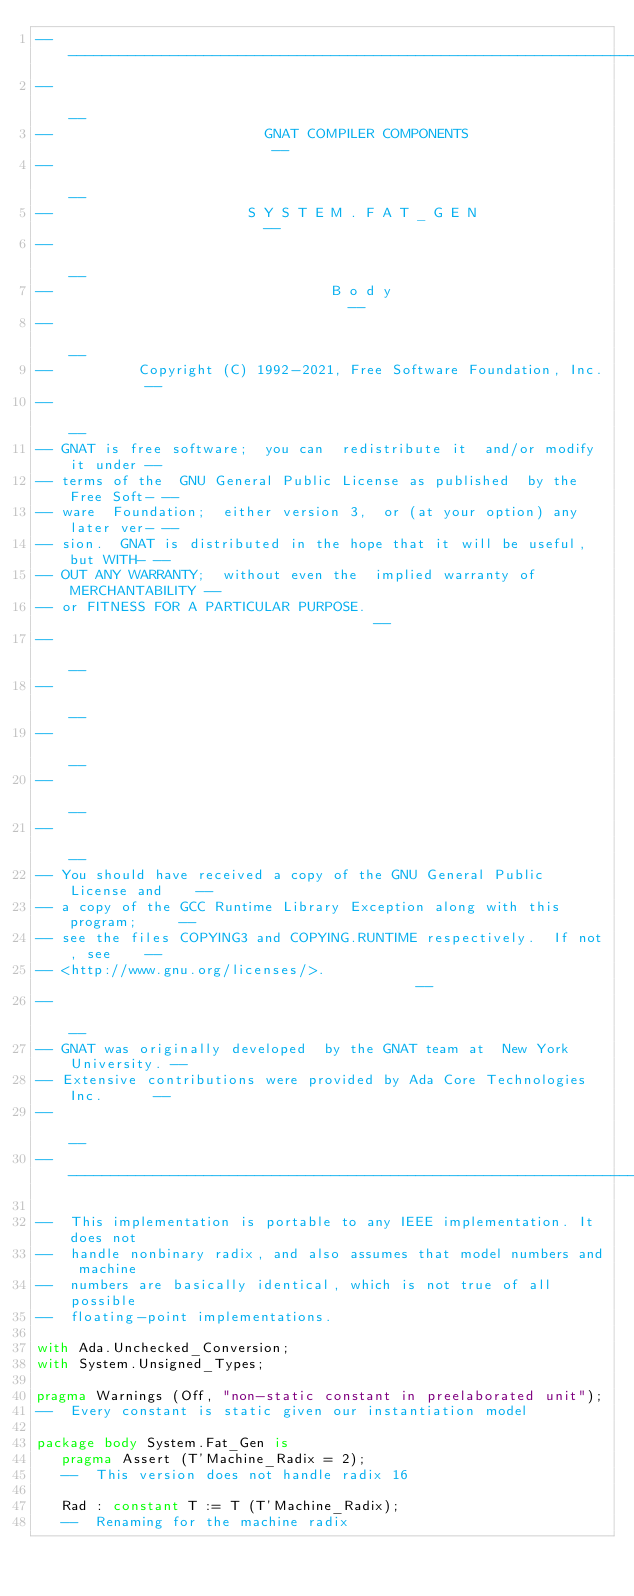Convert code to text. <code><loc_0><loc_0><loc_500><loc_500><_Ada_>------------------------------------------------------------------------------
--                                                                          --
--                         GNAT COMPILER COMPONENTS                         --
--                                                                          --
--                       S Y S T E M . F A T _ G E N                        --
--                                                                          --
--                                 B o d y                                  --
--                                                                          --
--          Copyright (C) 1992-2021, Free Software Foundation, Inc.         --
--                                                                          --
-- GNAT is free software;  you can  redistribute it  and/or modify it under --
-- terms of the  GNU General Public License as published  by the Free Soft- --
-- ware  Foundation;  either version 3,  or (at your option) any later ver- --
-- sion.  GNAT is distributed in the hope that it will be useful, but WITH- --
-- OUT ANY WARRANTY;  without even the  implied warranty of MERCHANTABILITY --
-- or FITNESS FOR A PARTICULAR PURPOSE.                                     --
--                                                                          --
--                                                                          --
--                                                                          --
--                                                                          --
--                                                                          --
-- You should have received a copy of the GNU General Public License and    --
-- a copy of the GCC Runtime Library Exception along with this program;     --
-- see the files COPYING3 and COPYING.RUNTIME respectively.  If not, see    --
-- <http://www.gnu.org/licenses/>.                                          --
--                                                                          --
-- GNAT was originally developed  by the GNAT team at  New York University. --
-- Extensive contributions were provided by Ada Core Technologies Inc.      --
--                                                                          --
------------------------------------------------------------------------------

--  This implementation is portable to any IEEE implementation. It does not
--  handle nonbinary radix, and also assumes that model numbers and machine
--  numbers are basically identical, which is not true of all possible
--  floating-point implementations.

with Ada.Unchecked_Conversion;
with System.Unsigned_Types;

pragma Warnings (Off, "non-static constant in preelaborated unit");
--  Every constant is static given our instantiation model

package body System.Fat_Gen is
   pragma Assert (T'Machine_Radix = 2);
   --  This version does not handle radix 16

   Rad : constant T := T (T'Machine_Radix);
   --  Renaming for the machine radix
</code> 